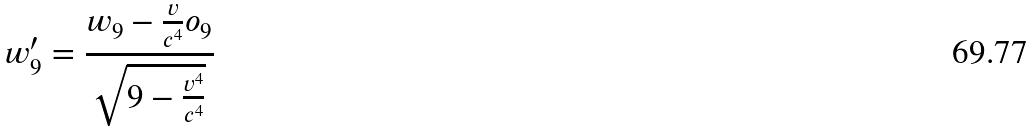Convert formula to latex. <formula><loc_0><loc_0><loc_500><loc_500>w _ { 9 } ^ { \prime } = \frac { w _ { 9 } - \frac { v } { c ^ { 4 } } o _ { 9 } } { \sqrt { 9 - \frac { v ^ { 4 } } { c ^ { 4 } } } }</formula> 